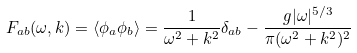Convert formula to latex. <formula><loc_0><loc_0><loc_500><loc_500>F _ { a b } ( \omega , k ) = \langle \phi _ { a } \phi _ { b } \rangle = \frac { 1 } { \omega ^ { 2 } + k ^ { 2 } } \delta _ { a b } - \frac { g | \omega | ^ { 5 / 3 } } { \pi ( \omega ^ { 2 } + k ^ { 2 } ) ^ { 2 } }</formula> 